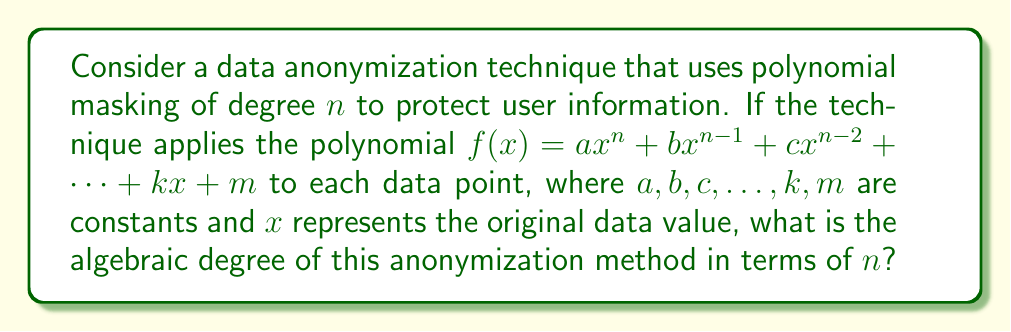Help me with this question. To determine the algebraic degree of this data anonymization technique, we need to analyze the polynomial used for masking:

1) The polynomial is given as:
   $$f(x) = ax^n + bx^{n-1} + cx^{n-2} + ... + kx + m$$

2) In algebraic geometry, the degree of a polynomial is determined by the highest power of the variable in the polynomial.

3) In this case, the highest power of $x$ is $n$.

4) The constants $a, b, c, ..., k, m$ do not affect the degree of the polynomial.

5) The lower degree terms ($x^{n-1}, x^{n-2}, ..., x, 1$) also do not impact the overall degree of the polynomial.

6) Therefore, the algebraic degree of this data anonymization technique is equal to the highest power of $x$ in the polynomial, which is $n$.

This high degree polynomial masking provides a strong level of data protection, as it significantly transforms the original data, making it difficult for unauthorized parties to reverse-engineer the original values.
Answer: $n$ 